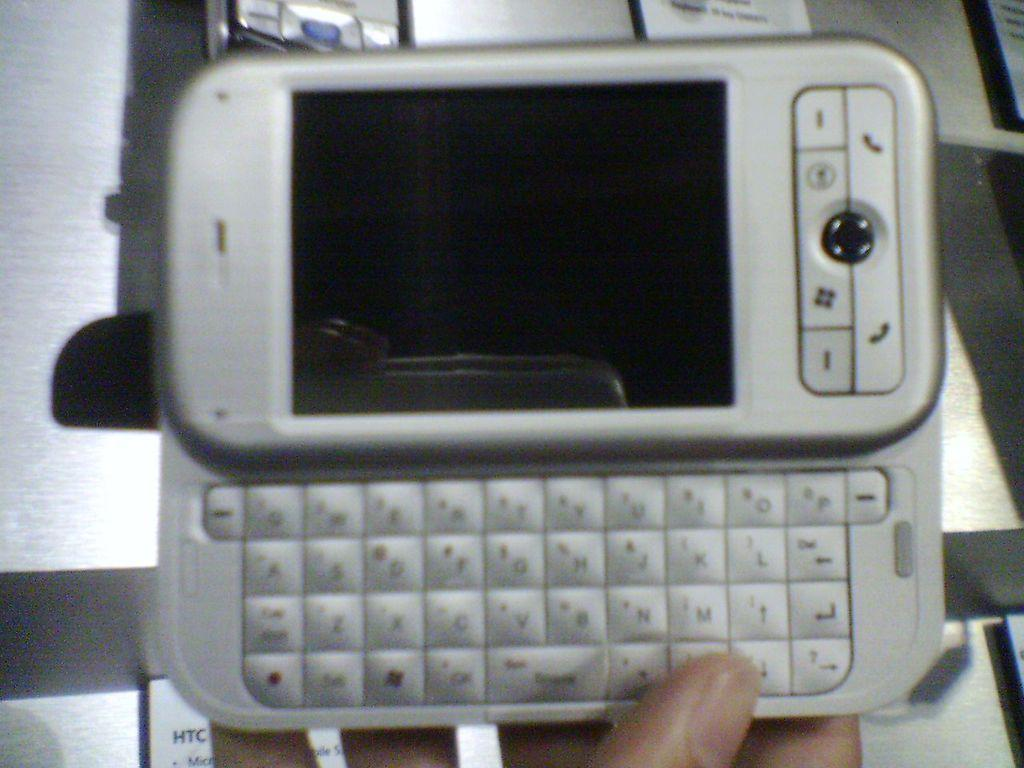What is the person holding in the image? There is a person's hand holding a mobile phone in the image. What type of device is visible in the image? There is a cellphone visible in the image. What else is placed on the table in the image? There is a paper with text on it in the image. Where are the cellphone and paper located in the image? The cellphone and paper are placed on a table. What type of rifle is the person holding in the image? There is no rifle present in the image; the person is holding a mobile phone. Can you describe the secretary's role in the image? There is no secretary present in the image. 